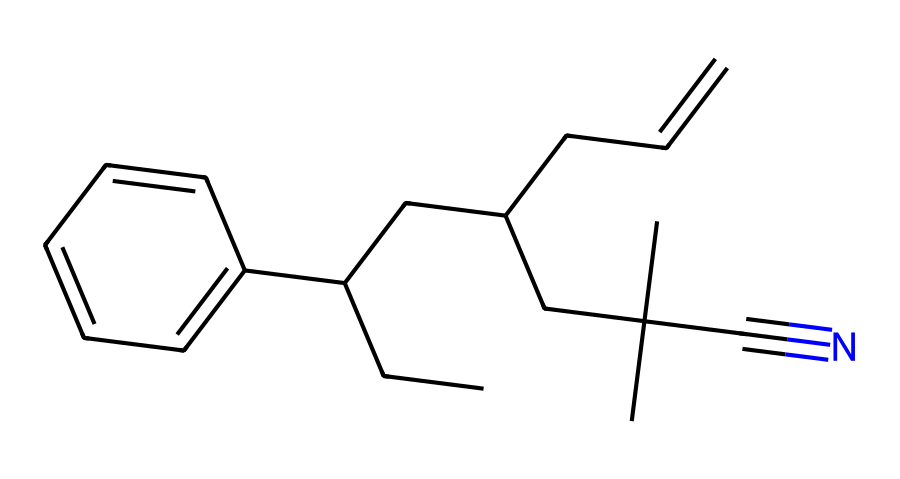What is the main functional group present in acrylonitrile butadiene styrene (ABS)? The main functional group in the structure is the nitrile group, indicated by the presence of the carbon triple-bonded to nitrogen (C#N).
Answer: nitrile How many carbon atoms are present in the structure of ABS? By analyzing the SMILES representation, there are a total of 20 carbon atoms in the entire structure of acrylonitrile butadiene styrene.
Answer: 20 What is the characteristic feature that makes ABS a popular choice for 3D printing? The presence of both rigid and flexible components in the polymer backbone allows ABS to have good impact resistance and durability, which are ideal properties for 3D printed items.
Answer: impact resistance Which element contributes to the polymer's resistance to heat and chemicals? The presence of styrene in the structure contributes to the polymer's resistance to heat and chemicals due to its aromatic character.
Answer: styrene What type of polymerization process is used to create ABS? ABS is produced through a process called emulsion polymerization, which combines different types of monomers to form copolymers.
Answer: emulsion polymerization Which part of the structure indicates that ABS can be manufactured in different colors? The presence of benzene rings in the structure allows for various dyeing processes, enabling ABS to be produced in a wide range of colors.
Answer: benzene rings 